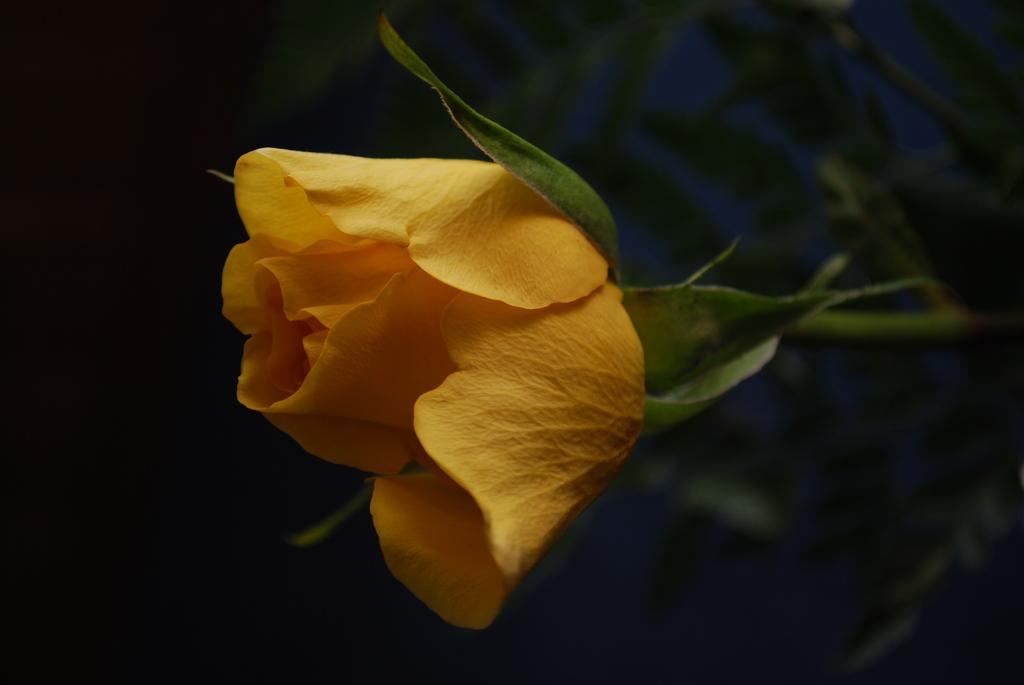What type of flower is in the image? There is a rose flower in the image. What color is the rose flower? The rose flower is yellow in color. Are there any cherries hanging from the rose flower in the image? No, there are no cherries present in the image, as it features a yellow rose flower. Is there a vest visible on the rose flower in the image? No, there is no vest present in the image, as it features a yellow rose flower. 